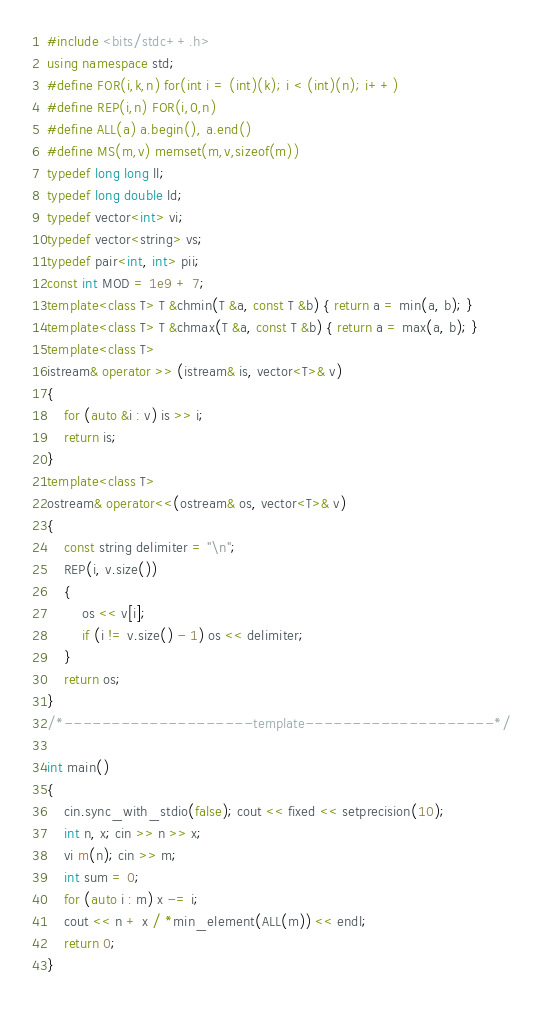Convert code to text. <code><loc_0><loc_0><loc_500><loc_500><_C++_>#include <bits/stdc++.h>
using namespace std;
#define FOR(i,k,n) for(int i = (int)(k); i < (int)(n); i++)
#define REP(i,n) FOR(i,0,n)
#define ALL(a) a.begin(), a.end()
#define MS(m,v) memset(m,v,sizeof(m))
typedef long long ll;
typedef long double ld;
typedef vector<int> vi;
typedef vector<string> vs;
typedef pair<int, int> pii;
const int MOD = 1e9 + 7;
template<class T> T &chmin(T &a, const T &b) { return a = min(a, b); }
template<class T> T &chmax(T &a, const T &b) { return a = max(a, b); }
template<class T>
istream& operator >> (istream& is, vector<T>& v)
{
	for (auto &i : v) is >> i;
	return is;
}
template<class T>
ostream& operator<<(ostream& os, vector<T>& v)
{
	const string delimiter = "\n";
	REP(i, v.size())
	{
		os << v[i];
		if (i != v.size() - 1) os << delimiter;
	}
	return os;
}
/*--------------------template--------------------*/

int main()
{
	cin.sync_with_stdio(false); cout << fixed << setprecision(10);
	int n, x; cin >> n >> x;
	vi m(n); cin >> m;
	int sum = 0;
	for (auto i : m) x -= i;
	cout << n + x / *min_element(ALL(m)) << endl;
	return 0;
}</code> 